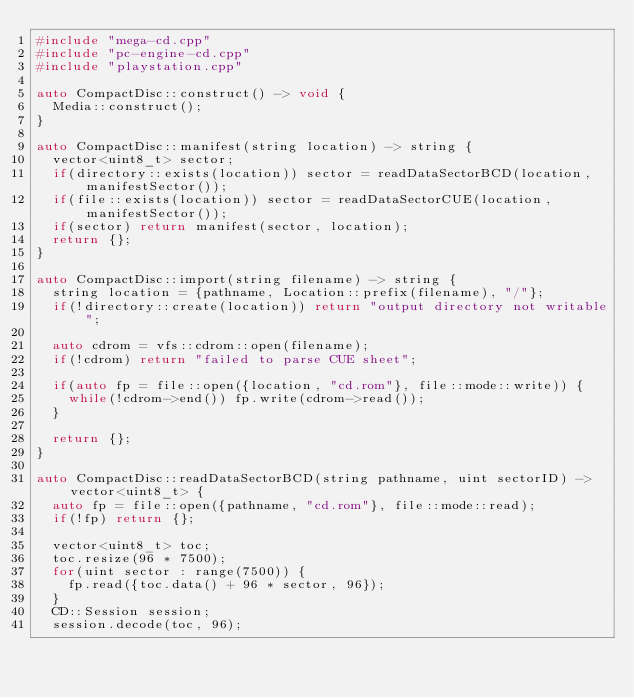<code> <loc_0><loc_0><loc_500><loc_500><_C++_>#include "mega-cd.cpp"
#include "pc-engine-cd.cpp"
#include "playstation.cpp"

auto CompactDisc::construct() -> void {
  Media::construct();
}

auto CompactDisc::manifest(string location) -> string {
  vector<uint8_t> sector;
  if(directory::exists(location)) sector = readDataSectorBCD(location, manifestSector());
  if(file::exists(location)) sector = readDataSectorCUE(location, manifestSector());
  if(sector) return manifest(sector, location);
  return {};
}

auto CompactDisc::import(string filename) -> string {
  string location = {pathname, Location::prefix(filename), "/"};
  if(!directory::create(location)) return "output directory not writable";

  auto cdrom = vfs::cdrom::open(filename);
  if(!cdrom) return "failed to parse CUE sheet";

  if(auto fp = file::open({location, "cd.rom"}, file::mode::write)) {
    while(!cdrom->end()) fp.write(cdrom->read());
  }

  return {};
}

auto CompactDisc::readDataSectorBCD(string pathname, uint sectorID) -> vector<uint8_t> {
  auto fp = file::open({pathname, "cd.rom"}, file::mode::read);
  if(!fp) return {};

  vector<uint8_t> toc;
  toc.resize(96 * 7500);
  for(uint sector : range(7500)) {
    fp.read({toc.data() + 96 * sector, 96});
  }
  CD::Session session;
  session.decode(toc, 96);
</code> 